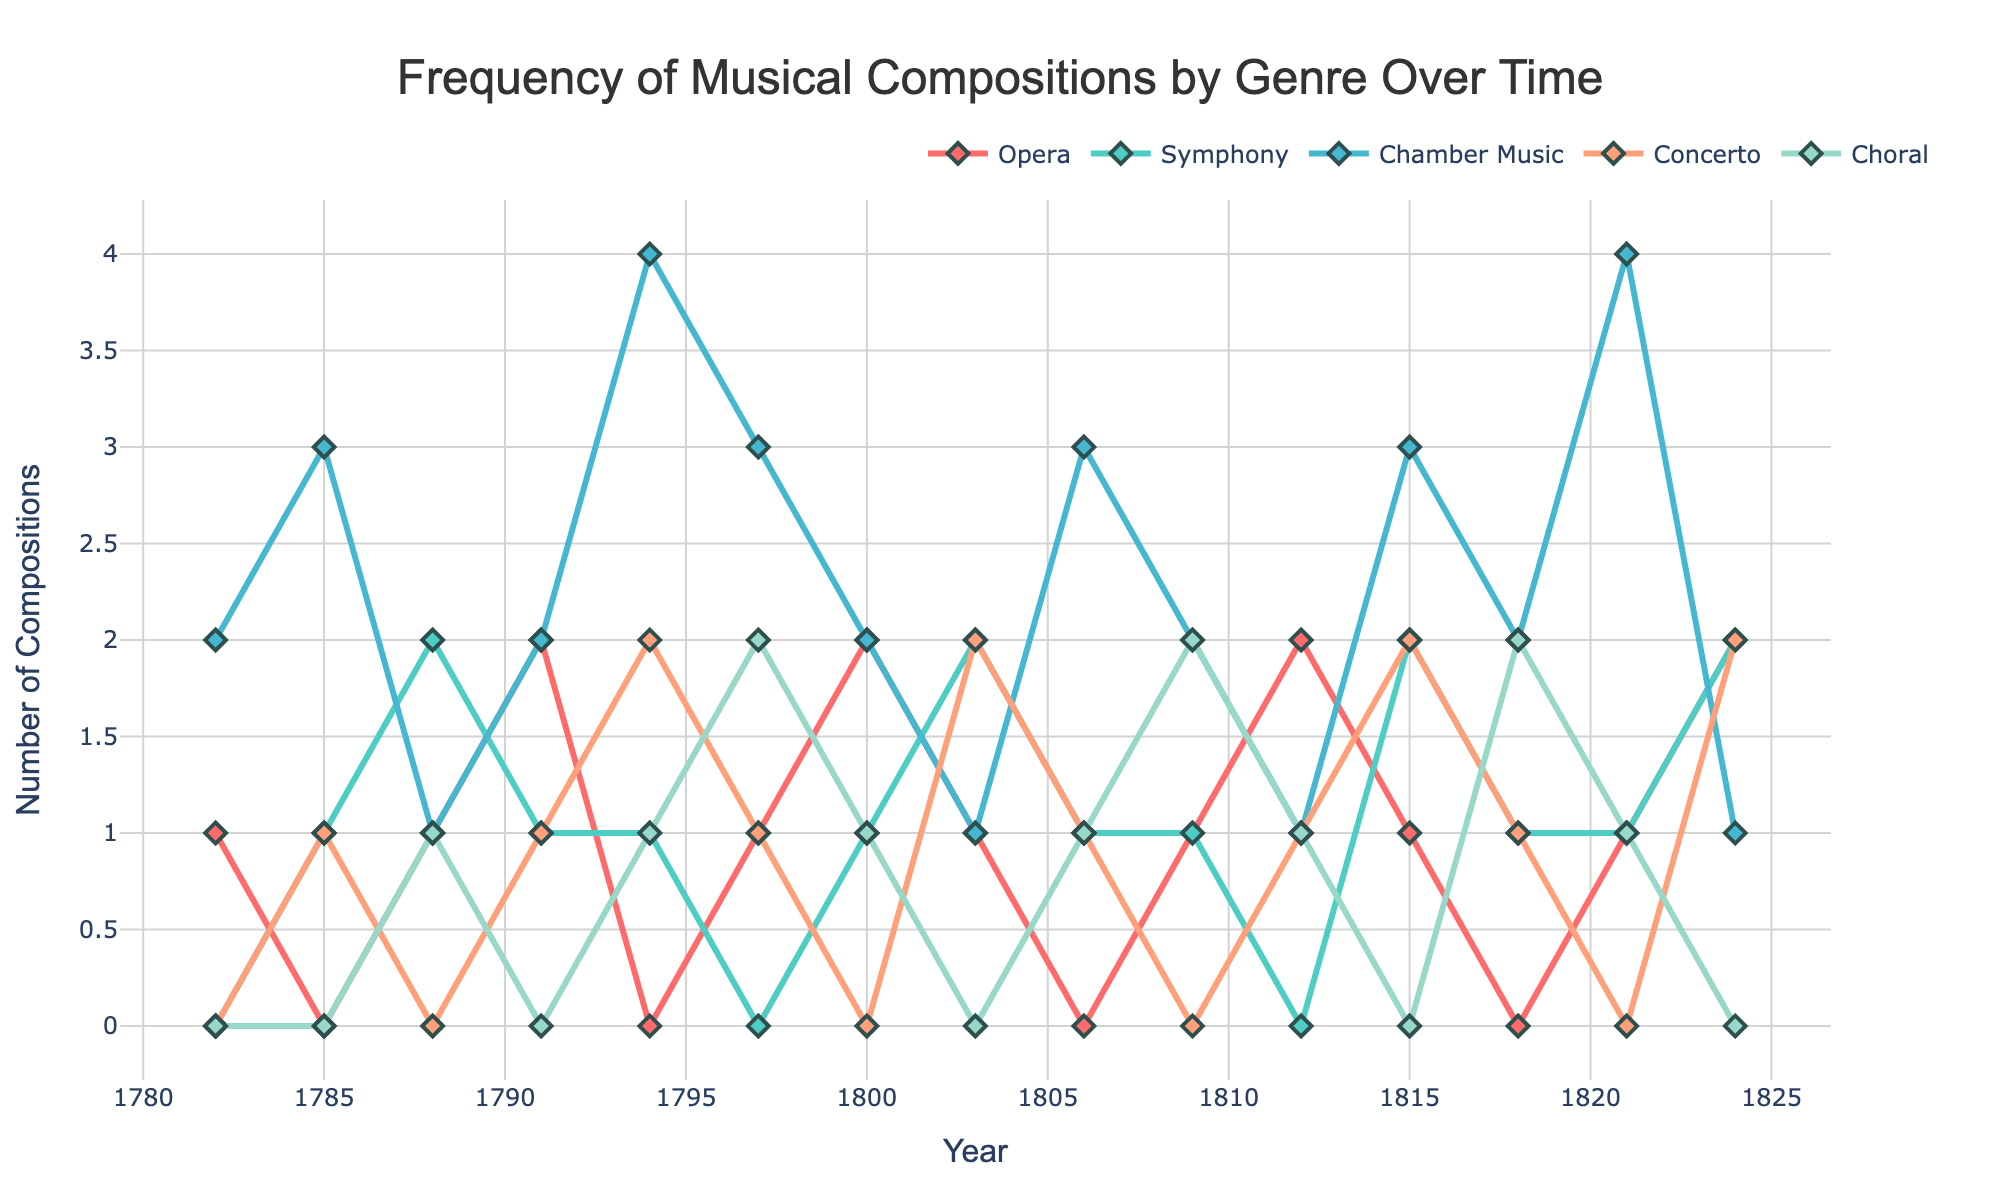what year saw the highest number of opera compositions? Look at the line representing opera compositions and identify the year where it peaks. The peak occurs in 1800 and 1824 with 2 compositions each.
Answer: 1800 and 1824 how many total symphonies were composed between 1782 and 1791? Sum the values of symphonies from the years 1782 to 1791 (0 + 1 + 2 + 1) = 4
Answer: 4 in which year did the composer create the most chamber music? Look at the line representing chamber music and identify the highest point. The peak occurs in 1794 and 1821 with 4 compositions each.
Answer: 1794 and 1821 how does the number of choral compositions in 1824 compare to those in 1800? Compare the values of choral compositions in 1824 (0) and 1800 (1). The value in 1800 is higher.
Answer: 1800 is higher calculate the average number of concertos composed per year from 1794 to 1812. Sum the values of concertos from 1794 to 1812 (2 + 1 + 2 + 1 + 1) = 7, then divide by the number of years (5). The average is 7/5 = 1.4
Answer: 1.4 which musical genre appears most frequently between 1800 and 1821? Sum the values across all genres for each year from 1800 to 1821. Opera: 7, Symphony: 7, Chamber Music: 15, Concerto: 7, Choral: 7. Chamber music appears most frequently.
Answer: Chamber Music during which decade did the composer write the least number of opera compositions? Sum the number of opera compositions in each decade. For 1780s (2), 1790s (3), 1800s (4), 1810s (3), 1820s (3). The 1780s had the least number of opera compositions.
Answer: 1780s was there ever a year in which zero musical compositions were created across all genres? Check each year to see if there is any year with 0 compositions in all genres. All years have at least one composition in at least one genre.
Answer: No what is the total number of compositions across all genres in 1800? Sum the values across all genres for the year 1800 (2 + 1 + 2 + 0 + 1). The total is 6.
Answer: 6 